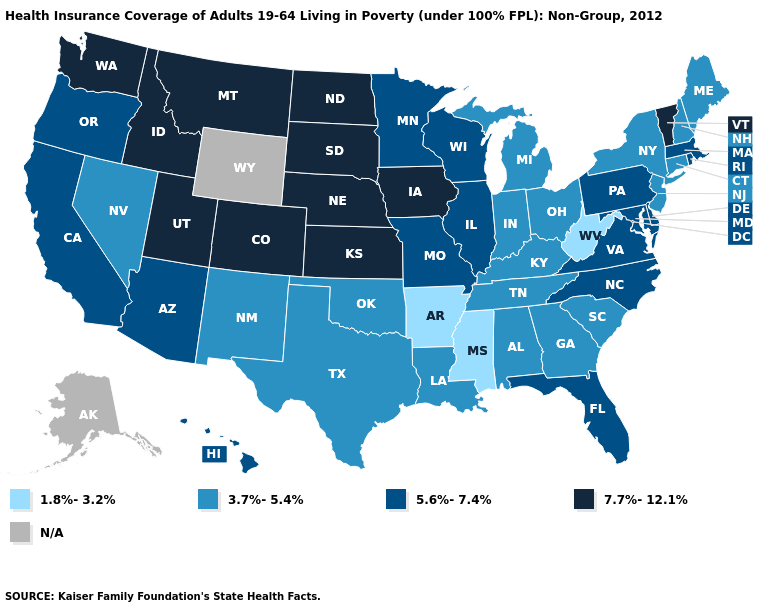Name the states that have a value in the range N/A?
Give a very brief answer. Alaska, Wyoming. What is the lowest value in states that border Connecticut?
Quick response, please. 3.7%-5.4%. What is the value of Wyoming?
Give a very brief answer. N/A. What is the value of Alabama?
Be succinct. 3.7%-5.4%. Name the states that have a value in the range 5.6%-7.4%?
Quick response, please. Arizona, California, Delaware, Florida, Hawaii, Illinois, Maryland, Massachusetts, Minnesota, Missouri, North Carolina, Oregon, Pennsylvania, Rhode Island, Virginia, Wisconsin. What is the value of Maryland?
Keep it brief. 5.6%-7.4%. How many symbols are there in the legend?
Write a very short answer. 5. Name the states that have a value in the range 5.6%-7.4%?
Quick response, please. Arizona, California, Delaware, Florida, Hawaii, Illinois, Maryland, Massachusetts, Minnesota, Missouri, North Carolina, Oregon, Pennsylvania, Rhode Island, Virginia, Wisconsin. Name the states that have a value in the range 5.6%-7.4%?
Be succinct. Arizona, California, Delaware, Florida, Hawaii, Illinois, Maryland, Massachusetts, Minnesota, Missouri, North Carolina, Oregon, Pennsylvania, Rhode Island, Virginia, Wisconsin. Name the states that have a value in the range 3.7%-5.4%?
Quick response, please. Alabama, Connecticut, Georgia, Indiana, Kentucky, Louisiana, Maine, Michigan, Nevada, New Hampshire, New Jersey, New Mexico, New York, Ohio, Oklahoma, South Carolina, Tennessee, Texas. What is the value of Maryland?
Short answer required. 5.6%-7.4%. Name the states that have a value in the range 7.7%-12.1%?
Answer briefly. Colorado, Idaho, Iowa, Kansas, Montana, Nebraska, North Dakota, South Dakota, Utah, Vermont, Washington. Name the states that have a value in the range 1.8%-3.2%?
Give a very brief answer. Arkansas, Mississippi, West Virginia. Which states have the lowest value in the West?
Keep it brief. Nevada, New Mexico. Does Iowa have the lowest value in the MidWest?
Give a very brief answer. No. 